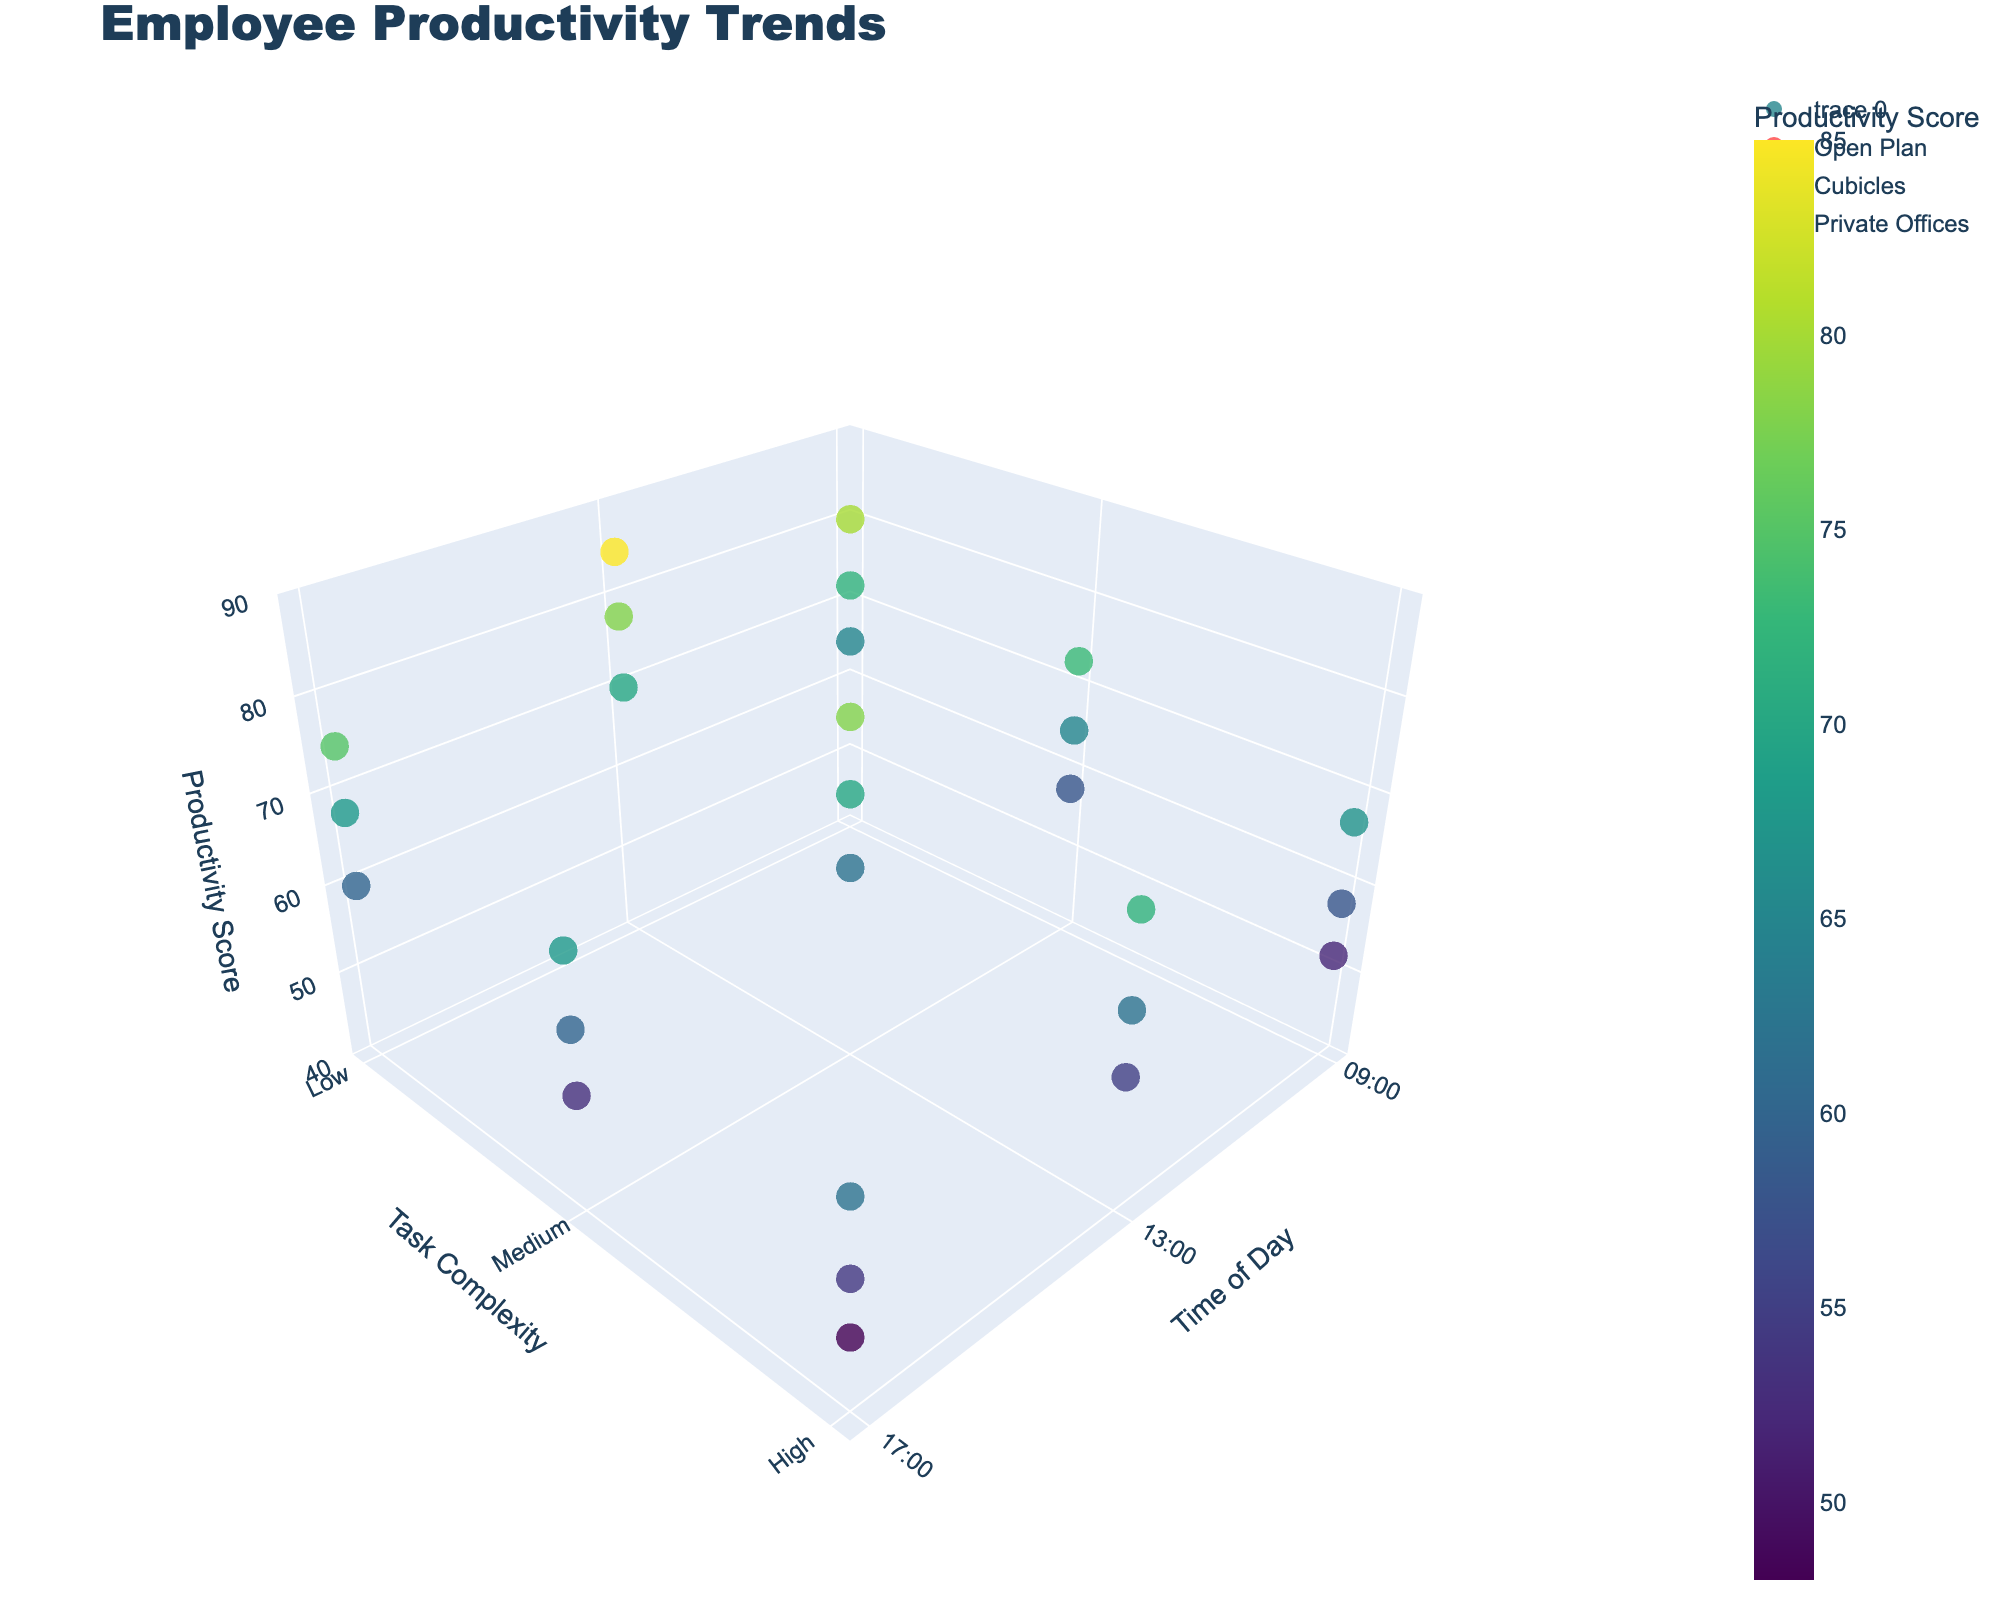What's the title of the 3D plot? The title of the plot is typically displayed prominently at the top of the figure. In this case, the title is mentioned in the plot layout parameters.
Answer: Employee Productivity Trends Which office layout shows the highest productivity score at 13:00 with low task complexity? Look at the plot, find the data points for 13:00 with low task complexity, and compare the productivity scores for different office layouts. The maximum value corresponds to "Private Offices."
Answer: Private Offices Compare the productivity score between Cubicles and Open Plan at 17:00 with medium task complexity. Which has a higher score? Locate the data points for 17:00 and medium task complexity for both Cubicles and Open Plan. Compare their productivity scores directly.
Answer: Cubicles What is the range of productivity scores displayed on the z-axis? Identify the minimum and maximum values on the z-axis of the 3D plot. From the plot parameters, the range is specified as [40, 90].
Answer: 40 to 90 How does the productivity trend vary between 09:00 and 17:00 for high task complexity in Cubicles? Compare the productivity scores for high task complexity within Cubicles at 09:00 and 17:00. Note the decrease or increase in scores.
Answer: Decreases Which office layout has the most consistent productivity scores over different times of day and task complexities? Look at the spread and variance of productivity scores for each office layout. The layout with the least spread indicates consistency.
Answer: Private Offices Which time of day generally shows the lowest productivity for Open Plan layout? Find the lowest productivity scores within the Open Plan layout across the times displayed on the x-axis: 09:00, 13:00, and 17:00.
Answer: 17:00 Compare the productivity scores at 09:00 for low, medium, and high task complexity in Private Offices. What pattern do you observe? Examine the productivity scores for 09:00 in Private Offices for low, medium, and high task complexity. Describe the trend or pattern in the scores.
Answer: Decreasing trend What is the productivity score for Open Plan with medium task complexity at 13:00? Locate the data point for Open Plan at 13:00 with medium task complexity and report its productivity score directly from the plot.
Answer: 62 Does the productivity trend for low task complexity consistently increase or decrease throughout the day for Private Offices? Look at the productivity scores for low task complexity in Private Offices at different times of the day (09:00, 13:00, 17:00) and determine the trend.
Answer: Decrease 